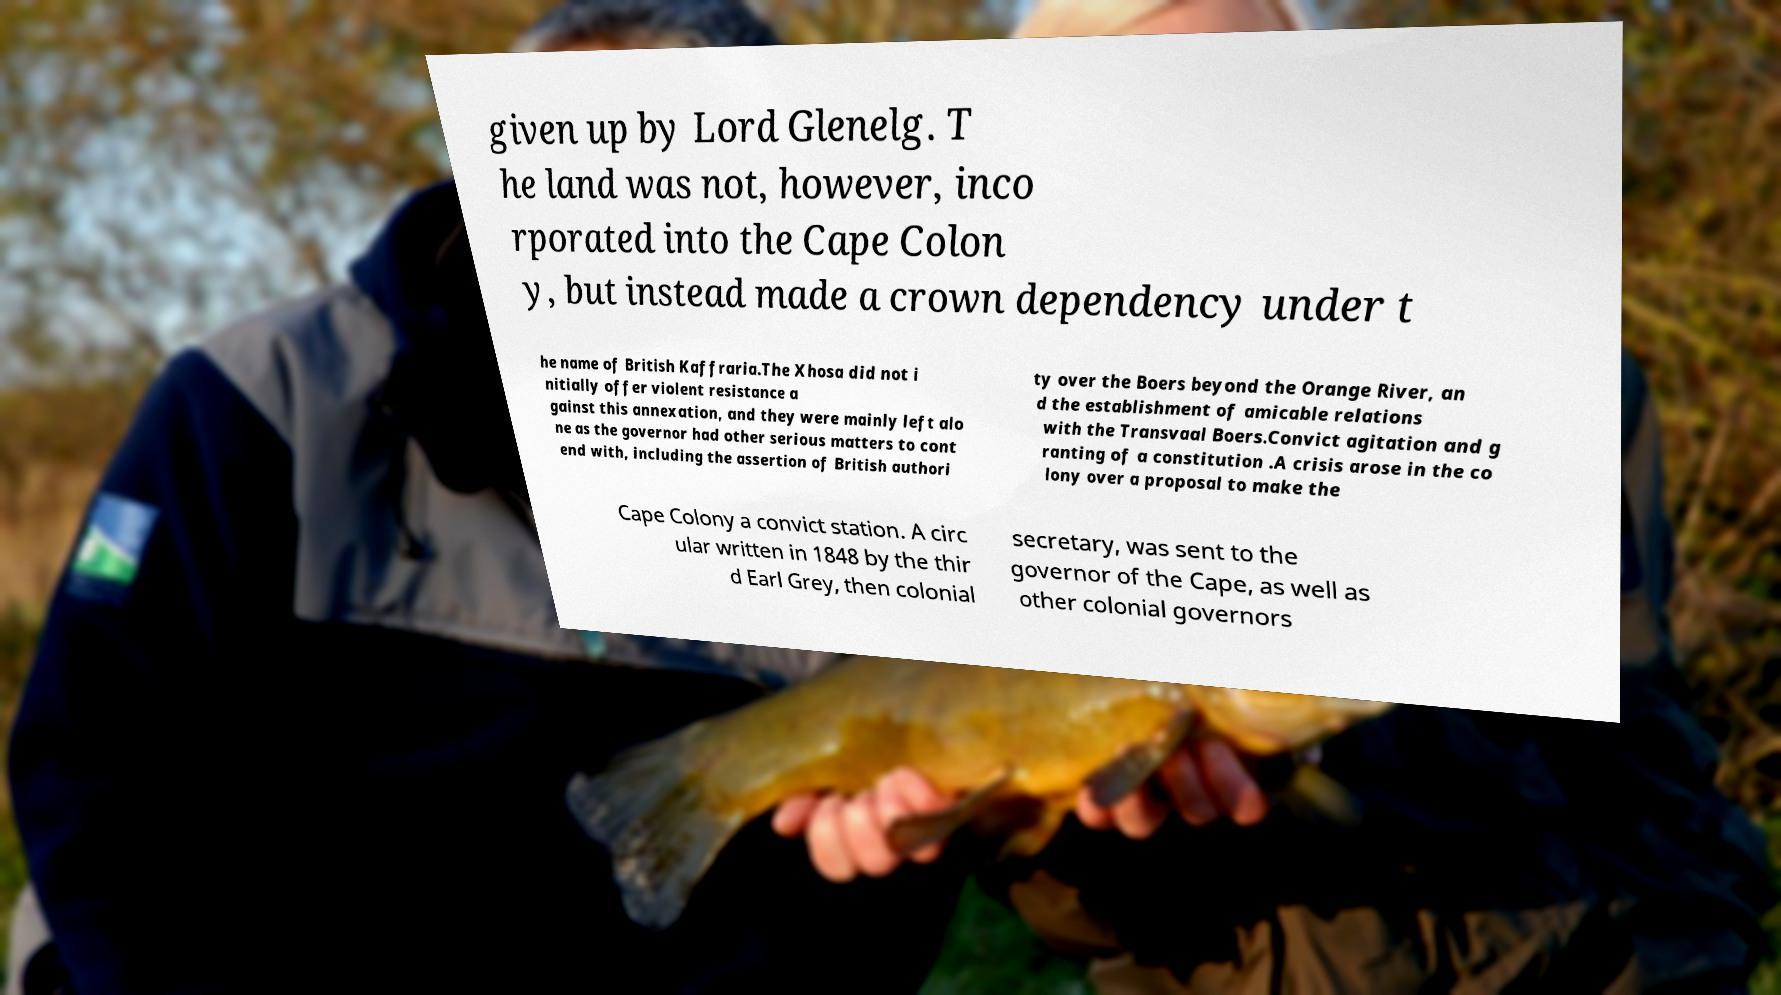Please read and relay the text visible in this image. What does it say? given up by Lord Glenelg. T he land was not, however, inco rporated into the Cape Colon y, but instead made a crown dependency under t he name of British Kaffraria.The Xhosa did not i nitially offer violent resistance a gainst this annexation, and they were mainly left alo ne as the governor had other serious matters to cont end with, including the assertion of British authori ty over the Boers beyond the Orange River, an d the establishment of amicable relations with the Transvaal Boers.Convict agitation and g ranting of a constitution .A crisis arose in the co lony over a proposal to make the Cape Colony a convict station. A circ ular written in 1848 by the thir d Earl Grey, then colonial secretary, was sent to the governor of the Cape, as well as other colonial governors 